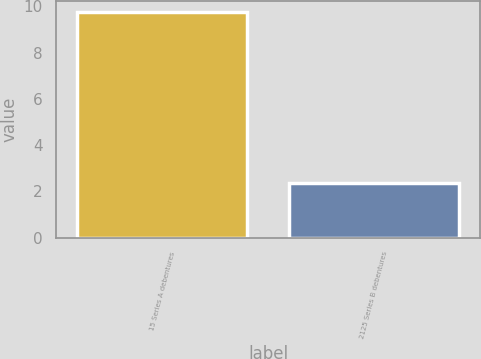<chart> <loc_0><loc_0><loc_500><loc_500><bar_chart><fcel>15 Series A debentures<fcel>2125 Series B debentures<nl><fcel>9.76<fcel>2.36<nl></chart> 